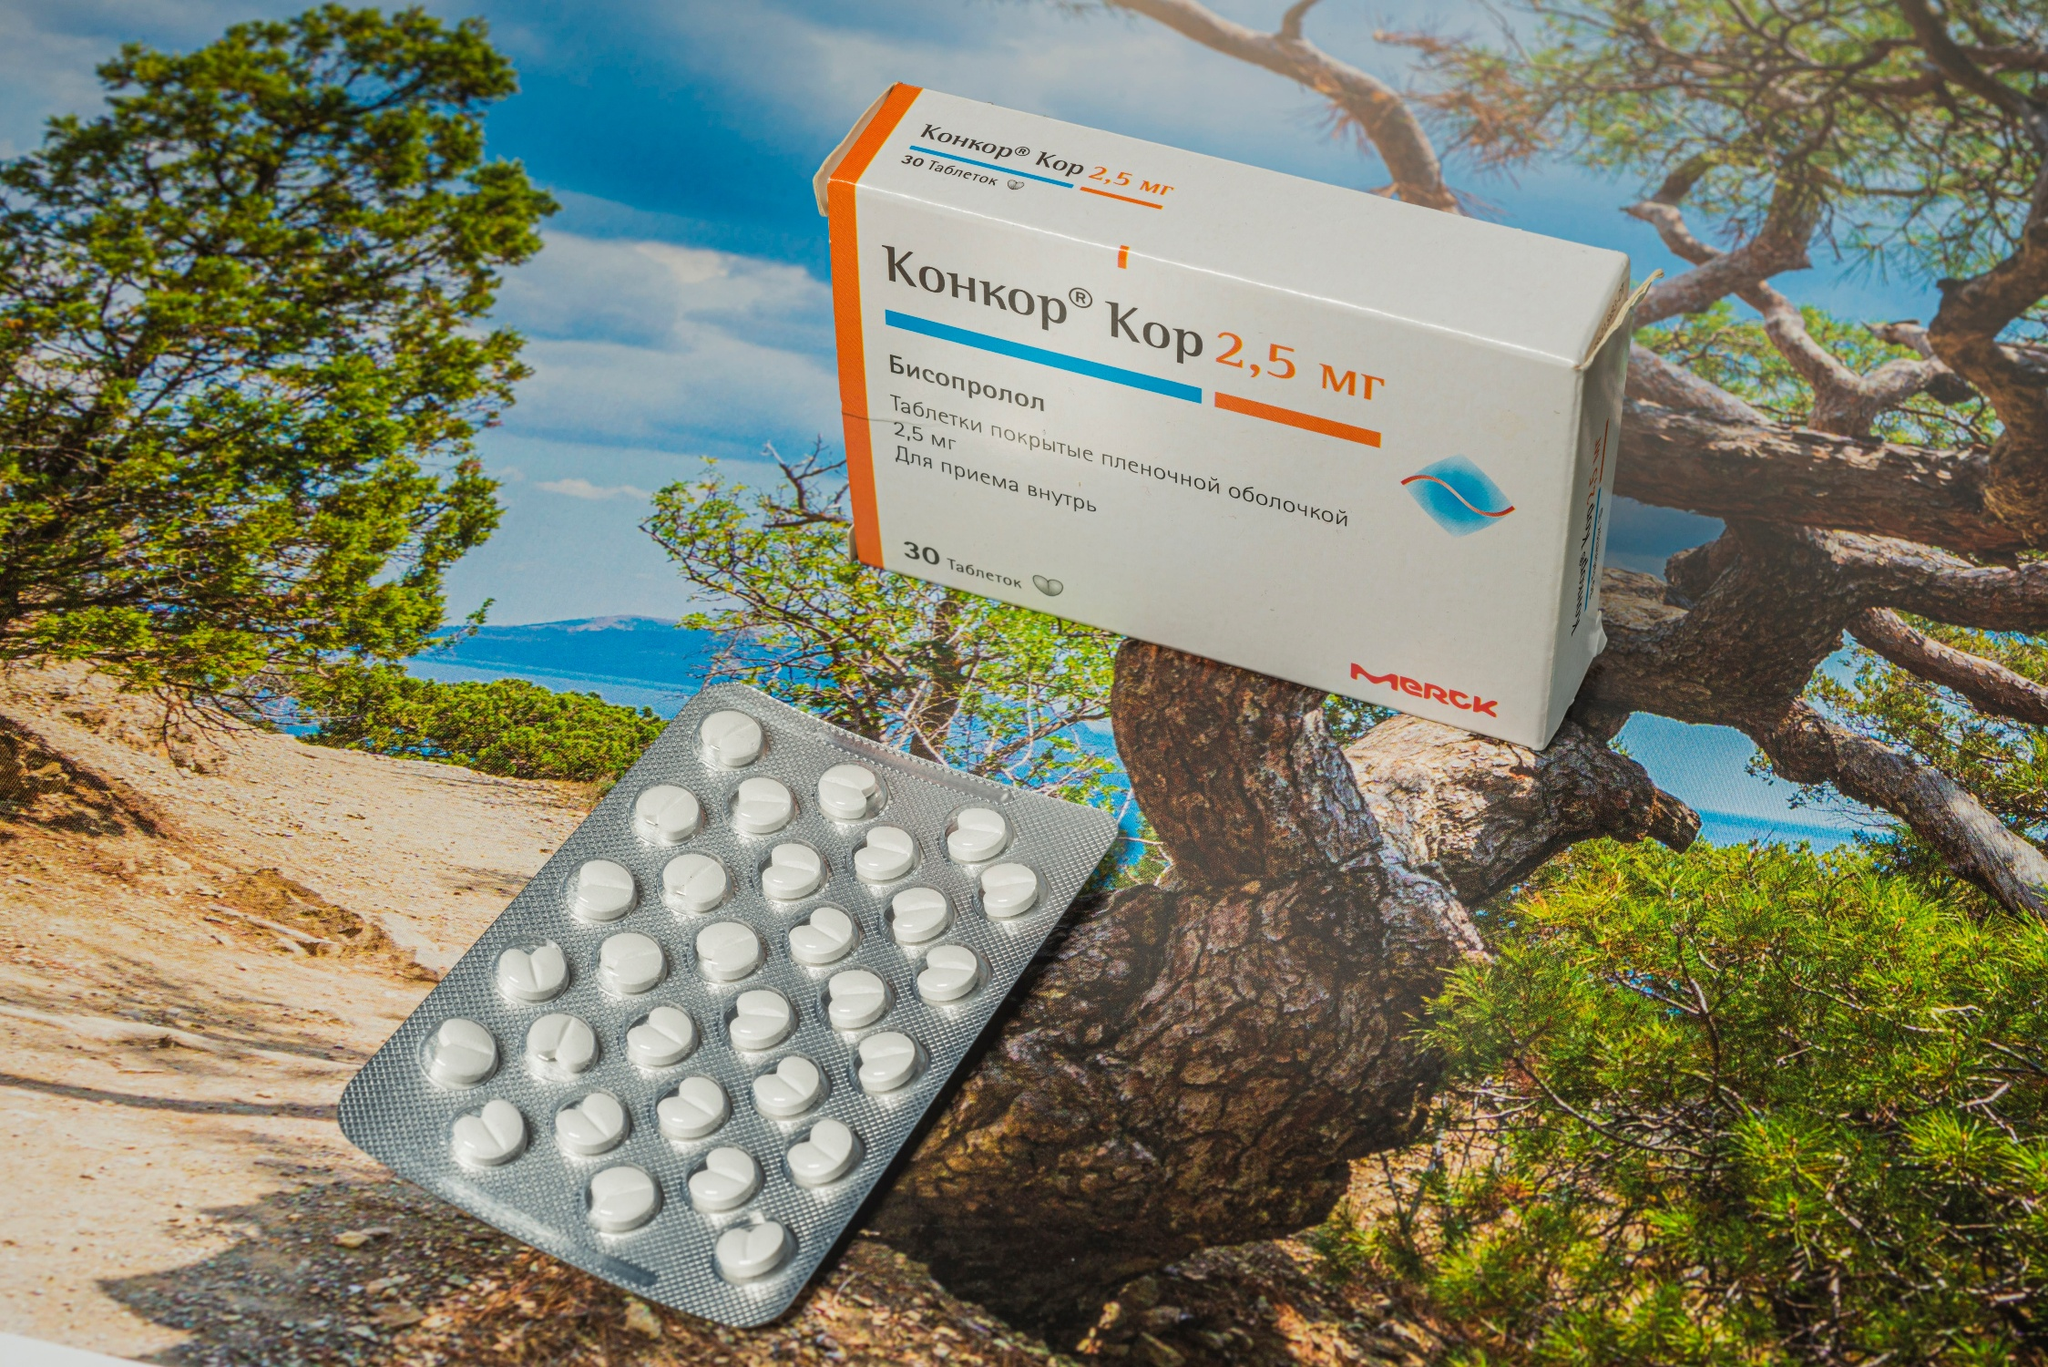How does the positioning of the medical products in a natural setting like this affect the viewer's perception of the image? By placing medical items such as the Concor Kor 2.5 mg pills in a natural environment, the image might evoke a sense of contrast between human-created medicinal products and the raw, untamed aspects of nature. This juxtaposition could lead viewers to reflect on the themes of health and nature’s role in it, possibly seeing the medication as a necessity that bridges the gap between human health challenges and the natural world’s tranquility. 